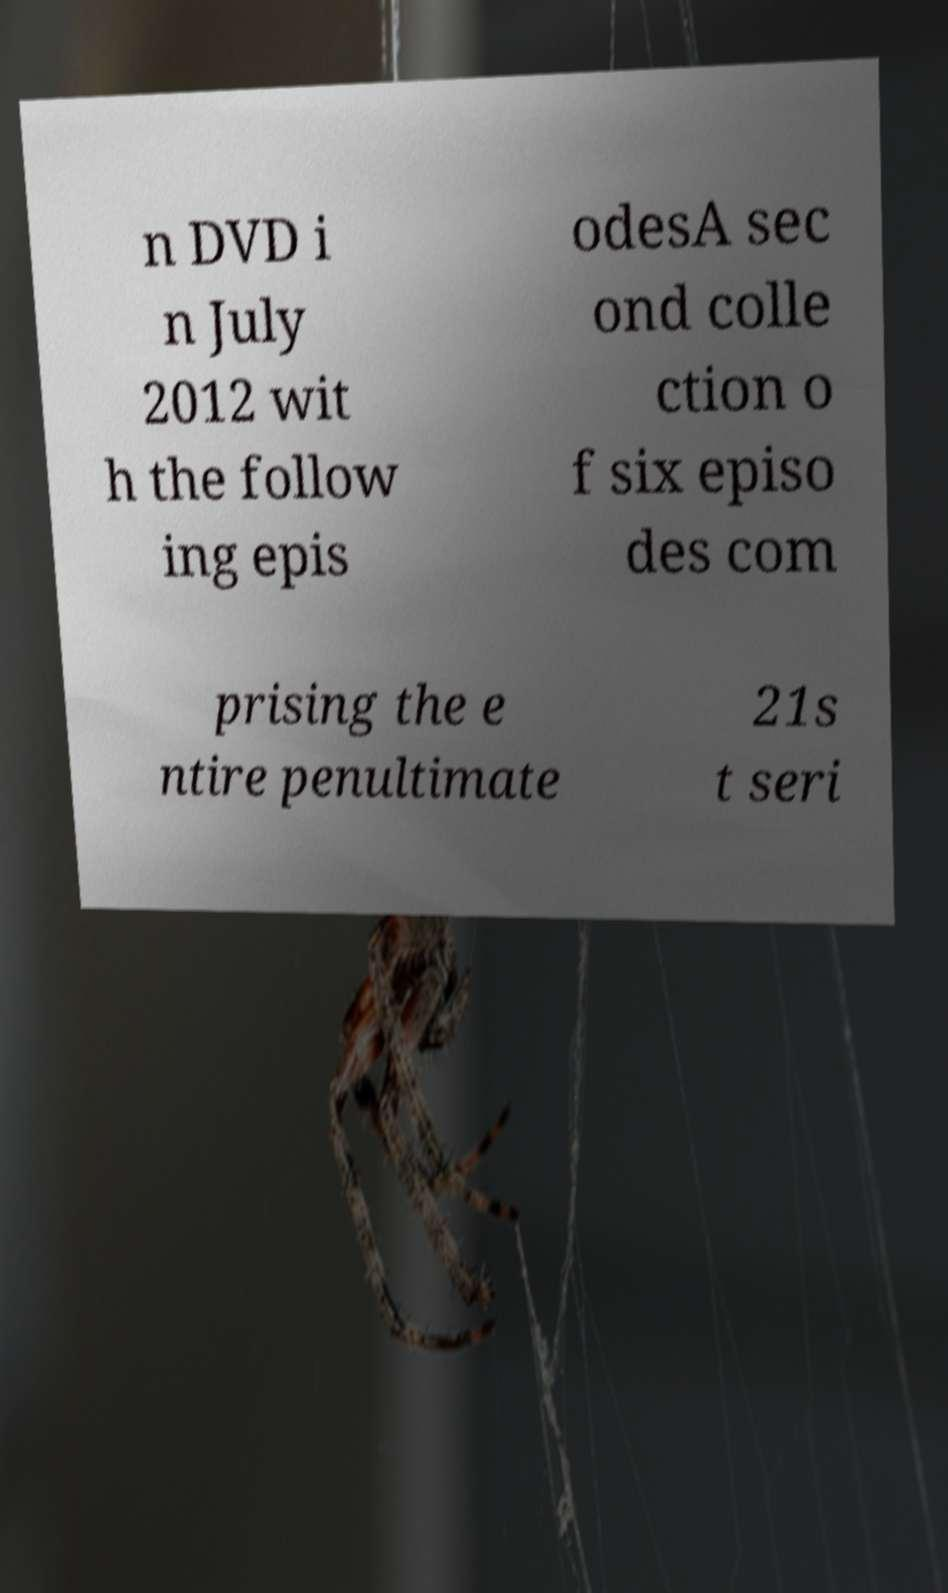There's text embedded in this image that I need extracted. Can you transcribe it verbatim? n DVD i n July 2012 wit h the follow ing epis odesA sec ond colle ction o f six episo des com prising the e ntire penultimate 21s t seri 